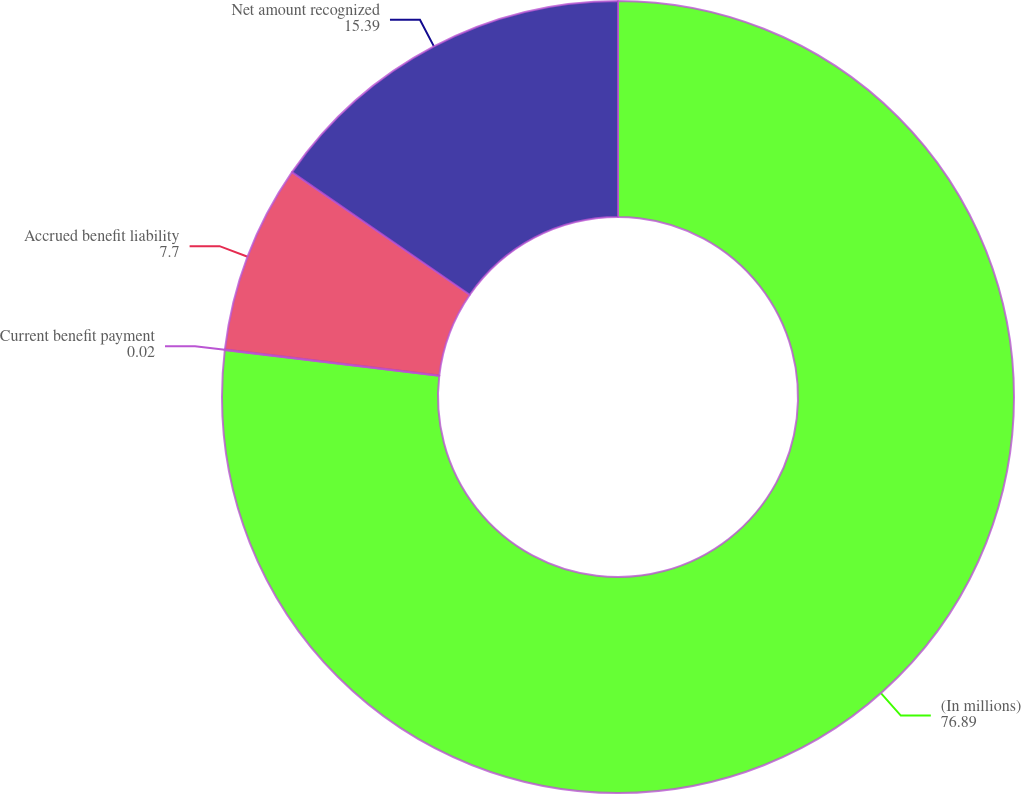Convert chart. <chart><loc_0><loc_0><loc_500><loc_500><pie_chart><fcel>(In millions)<fcel>Current benefit payment<fcel>Accrued benefit liability<fcel>Net amount recognized<nl><fcel>76.89%<fcel>0.02%<fcel>7.7%<fcel>15.39%<nl></chart> 